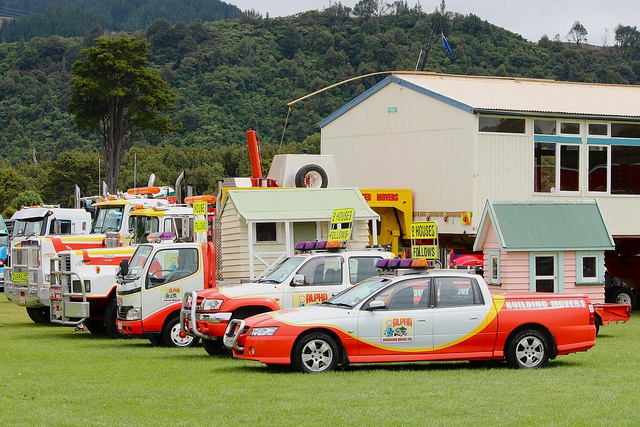Describe the objects in this image and their specific colors. I can see truck in blue, lightgray, red, darkgray, and black tones, truck in blue, lightgray, black, darkgray, and gray tones, truck in blue, lightgray, darkgray, gray, and black tones, truck in blue, lightgray, darkgray, black, and gray tones, and truck in blue, darkgray, lightgray, and gray tones in this image. 